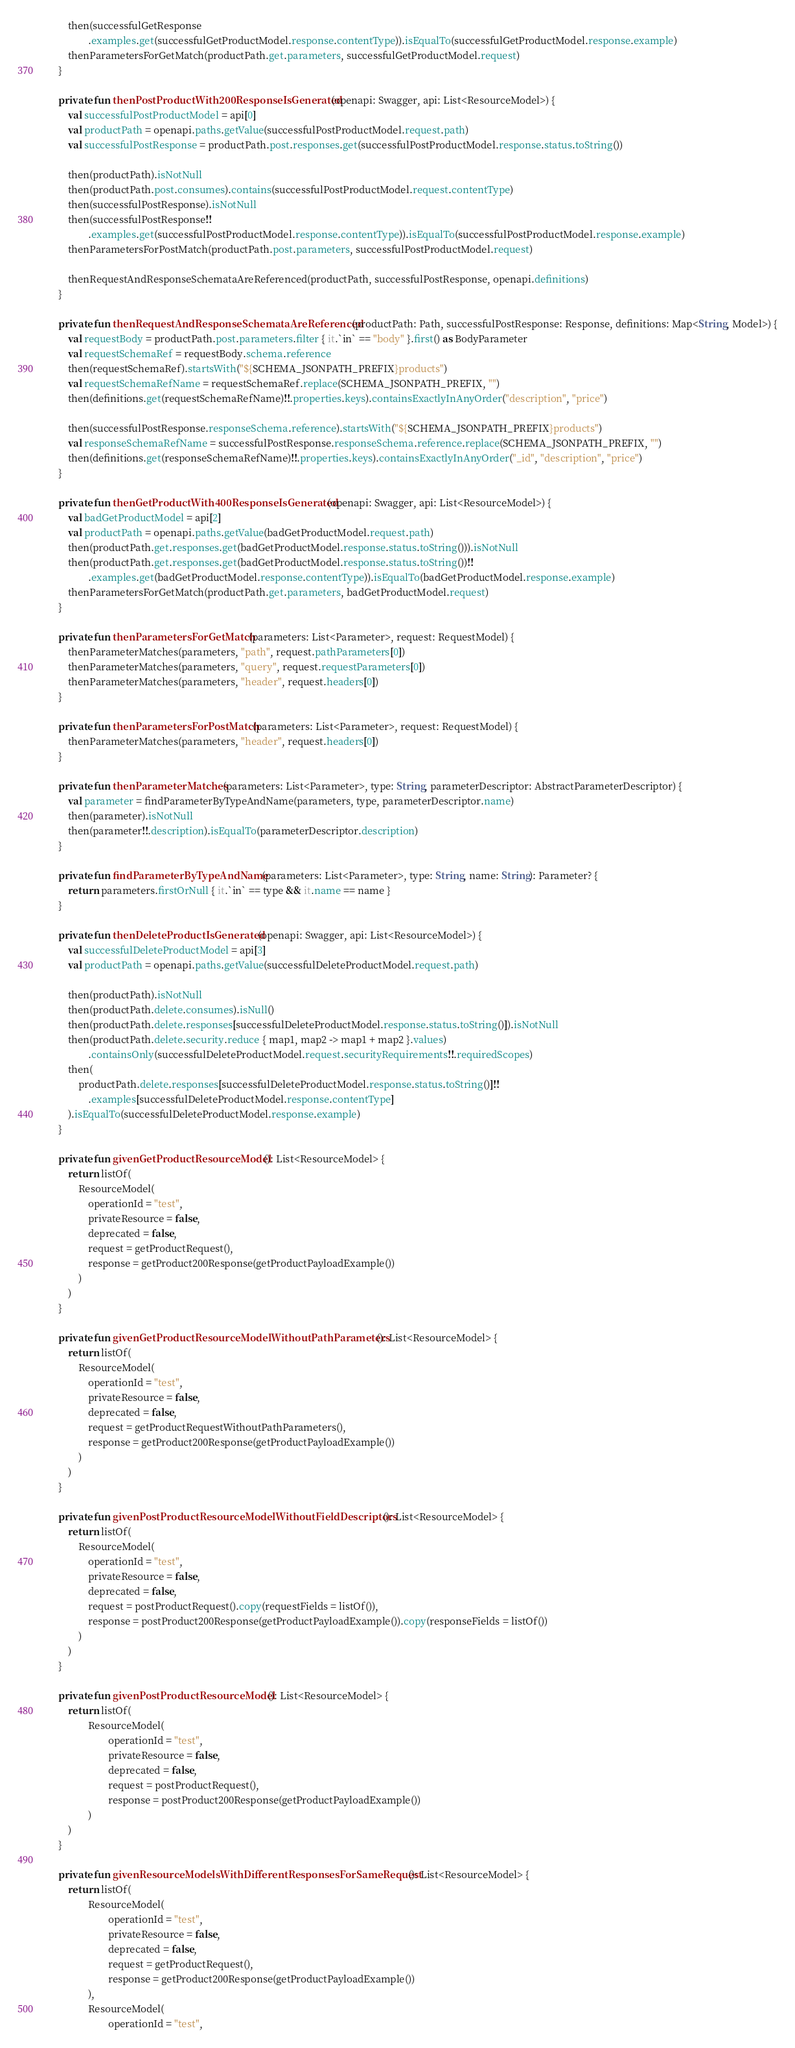<code> <loc_0><loc_0><loc_500><loc_500><_Kotlin_>
        then(successfulGetResponse
                .examples.get(successfulGetProductModel.response.contentType)).isEqualTo(successfulGetProductModel.response.example)
        thenParametersForGetMatch(productPath.get.parameters, successfulGetProductModel.request)
    }

    private fun thenPostProductWith200ResponseIsGenerated(openapi: Swagger, api: List<ResourceModel>) {
        val successfulPostProductModel = api[0]
        val productPath = openapi.paths.getValue(successfulPostProductModel.request.path)
        val successfulPostResponse = productPath.post.responses.get(successfulPostProductModel.response.status.toString())

        then(productPath).isNotNull
        then(productPath.post.consumes).contains(successfulPostProductModel.request.contentType)
        then(successfulPostResponse).isNotNull
        then(successfulPostResponse!!
                .examples.get(successfulPostProductModel.response.contentType)).isEqualTo(successfulPostProductModel.response.example)
        thenParametersForPostMatch(productPath.post.parameters, successfulPostProductModel.request)

        thenRequestAndResponseSchemataAreReferenced(productPath, successfulPostResponse, openapi.definitions)
    }

    private fun thenRequestAndResponseSchemataAreReferenced(productPath: Path, successfulPostResponse: Response, definitions: Map<String, Model>) {
        val requestBody = productPath.post.parameters.filter { it.`in` == "body" }.first() as BodyParameter
        val requestSchemaRef = requestBody.schema.reference
        then(requestSchemaRef).startsWith("${SCHEMA_JSONPATH_PREFIX}products")
        val requestSchemaRefName = requestSchemaRef.replace(SCHEMA_JSONPATH_PREFIX, "")
        then(definitions.get(requestSchemaRefName)!!.properties.keys).containsExactlyInAnyOrder("description", "price")

        then(successfulPostResponse.responseSchema.reference).startsWith("${SCHEMA_JSONPATH_PREFIX}products")
        val responseSchemaRefName = successfulPostResponse.responseSchema.reference.replace(SCHEMA_JSONPATH_PREFIX, "")
        then(definitions.get(responseSchemaRefName)!!.properties.keys).containsExactlyInAnyOrder("_id", "description", "price")
    }

    private fun thenGetProductWith400ResponseIsGenerated(openapi: Swagger, api: List<ResourceModel>) {
        val badGetProductModel = api[2]
        val productPath = openapi.paths.getValue(badGetProductModel.request.path)
        then(productPath.get.responses.get(badGetProductModel.response.status.toString())).isNotNull
        then(productPath.get.responses.get(badGetProductModel.response.status.toString())!!
                .examples.get(badGetProductModel.response.contentType)).isEqualTo(badGetProductModel.response.example)
        thenParametersForGetMatch(productPath.get.parameters, badGetProductModel.request)
    }

    private fun thenParametersForGetMatch(parameters: List<Parameter>, request: RequestModel) {
        thenParameterMatches(parameters, "path", request.pathParameters[0])
        thenParameterMatches(parameters, "query", request.requestParameters[0])
        thenParameterMatches(parameters, "header", request.headers[0])
    }

    private fun thenParametersForPostMatch(parameters: List<Parameter>, request: RequestModel) {
        thenParameterMatches(parameters, "header", request.headers[0])
    }

    private fun thenParameterMatches(parameters: List<Parameter>, type: String, parameterDescriptor: AbstractParameterDescriptor) {
        val parameter = findParameterByTypeAndName(parameters, type, parameterDescriptor.name)
        then(parameter).isNotNull
        then(parameter!!.description).isEqualTo(parameterDescriptor.description)
    }

    private fun findParameterByTypeAndName(parameters: List<Parameter>, type: String, name: String): Parameter? {
        return parameters.firstOrNull { it.`in` == type && it.name == name }
    }

    private fun thenDeleteProductIsGenerated(openapi: Swagger, api: List<ResourceModel>) {
        val successfulDeleteProductModel = api[3]
        val productPath = openapi.paths.getValue(successfulDeleteProductModel.request.path)

        then(productPath).isNotNull
        then(productPath.delete.consumes).isNull()
        then(productPath.delete.responses[successfulDeleteProductModel.response.status.toString()]).isNotNull
        then(productPath.delete.security.reduce { map1, map2 -> map1 + map2 }.values)
                .containsOnly(successfulDeleteProductModel.request.securityRequirements!!.requiredScopes)
        then(
            productPath.delete.responses[successfulDeleteProductModel.response.status.toString()]!!
                .examples[successfulDeleteProductModel.response.contentType]
        ).isEqualTo(successfulDeleteProductModel.response.example)
    }

    private fun givenGetProductResourceModel(): List<ResourceModel> {
        return listOf(
            ResourceModel(
                operationId = "test",
                privateResource = false,
                deprecated = false,
                request = getProductRequest(),
                response = getProduct200Response(getProductPayloadExample())
            )
        )
    }

    private fun givenGetProductResourceModelWithoutPathParameters(): List<ResourceModel> {
        return listOf(
            ResourceModel(
                operationId = "test",
                privateResource = false,
                deprecated = false,
                request = getProductRequestWithoutPathParameters(),
                response = getProduct200Response(getProductPayloadExample())
            )
        )
    }

    private fun givenPostProductResourceModelWithoutFieldDescriptors(): List<ResourceModel> {
        return listOf(
            ResourceModel(
                operationId = "test",
                privateResource = false,
                deprecated = false,
                request = postProductRequest().copy(requestFields = listOf()),
                response = postProduct200Response(getProductPayloadExample()).copy(responseFields = listOf())
            )
        )
    }

    private fun givenPostProductResourceModel(): List<ResourceModel> {
        return listOf(
                ResourceModel(
                        operationId = "test",
                        privateResource = false,
                        deprecated = false,
                        request = postProductRequest(),
                        response = postProduct200Response(getProductPayloadExample())
                )
        )
    }

    private fun givenResourceModelsWithDifferentResponsesForSameRequest(): List<ResourceModel> {
        return listOf(
                ResourceModel(
                        operationId = "test",
                        privateResource = false,
                        deprecated = false,
                        request = getProductRequest(),
                        response = getProduct200Response(getProductPayloadExample())
                ),
                ResourceModel(
                        operationId = "test",</code> 